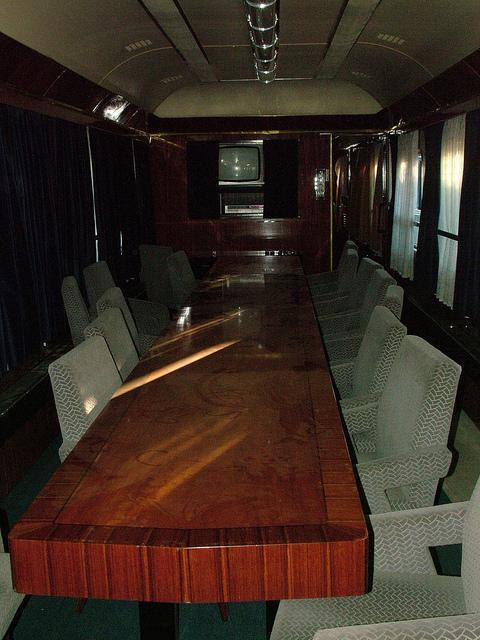How many chairs are in the photo?
Give a very brief answer. 6. How many train tracks are there?
Give a very brief answer. 0. 